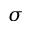Convert formula to latex. <formula><loc_0><loc_0><loc_500><loc_500>\sigma</formula> 